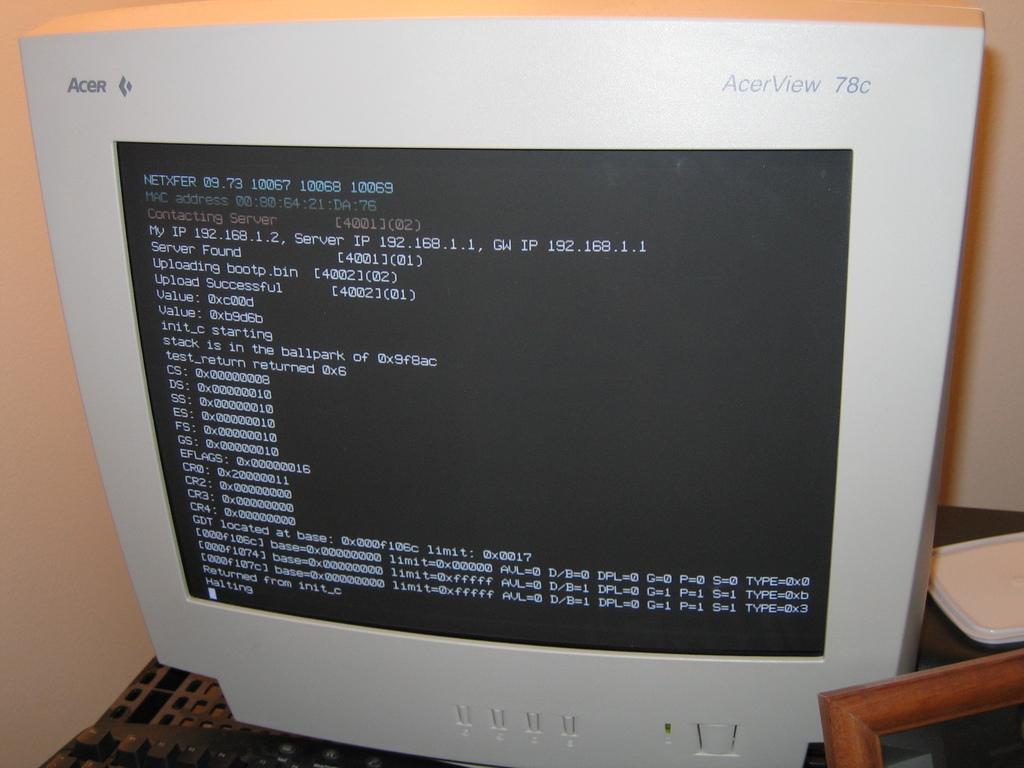What make of acer is this?
Offer a very short reply. Acerview 78c. 